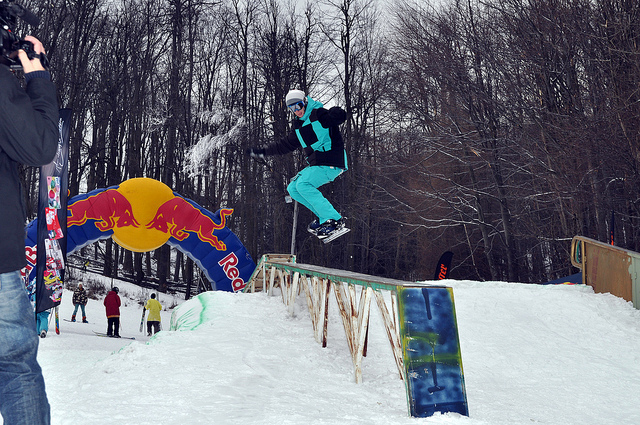<image>Which country is it? I don't know which country it is. It can be either USA or China. Which country is it? I am not sure which country it is. It can be either USA or China. 